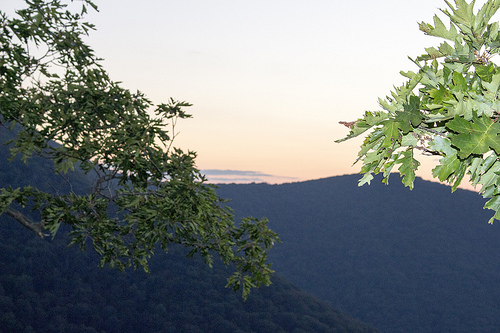<image>
Is the sky behind the tree? Yes. From this viewpoint, the sky is positioned behind the tree, with the tree partially or fully occluding the sky. 